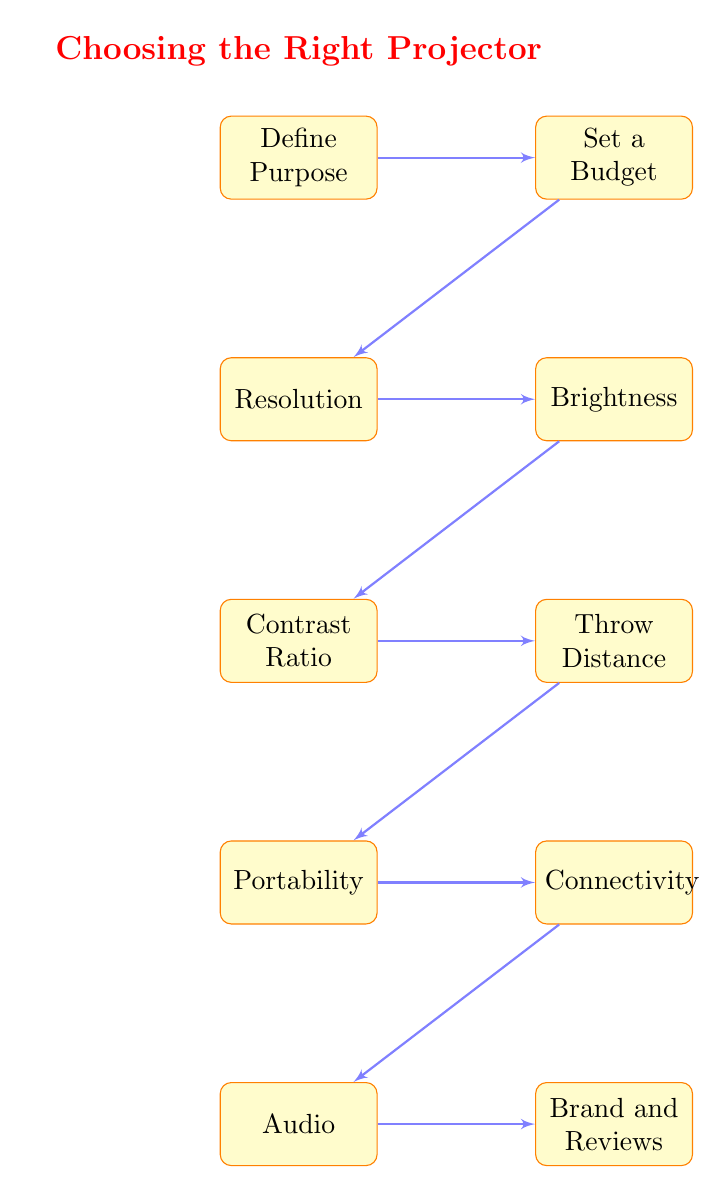What's the first step in the flowchart? The first step in the flowchart represents the initial stage of the decision-making process, which is "Define Purpose".
Answer: Define Purpose How many nodes are present in the flowchart? By counting each unique step in the flowchart, we find there are ten individual steps, or nodes, outlined.
Answer: 10 What follows after setting the budget? Following the "Set a Budget" step, the flowchart indicates that the next step is "Resolution".
Answer: Resolution What is the last element in the flowchart? The final node in the flowchart represents the conclusion of the process, which is "Brand and Reviews".
Answer: Brand and Reviews Which node is directly connected to "Throw Distance"? The node that is directly connected and follows "Throw Distance" is "Portability".
Answer: Portability What two factors need to be considered before "Brightness"? Before reaching "Brightness", both "Resolution" and "Set a Budget" need to be evaluated in the decision-making process.
Answer: Resolution, Set a Budget What connectivity options should be ensured for the projector? The flowchart emphasizes ensuring necessary inputs such as HDMI, USB, and WiFi under the "Connectivity" node.
Answer: HDMI, USB, WiFi If the purpose defined is gaming, what is the next step? After defining the purpose as gaming, the subsequent step listed in the flowchart is "Set a Budget".
Answer: Set a Budget Which step involves assessing audio capabilities? The specific step that addresses audio capabilities in the flowchart is labeled as "Audio".
Answer: Audio 